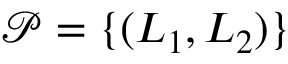Convert formula to latex. <formula><loc_0><loc_0><loc_500><loc_500>\mathcal { P } = \{ ( L _ { 1 } , L _ { 2 } ) \}</formula> 